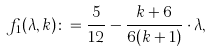Convert formula to latex. <formula><loc_0><loc_0><loc_500><loc_500>f _ { 1 } ( \lambda , k ) \colon = \frac { 5 } { 1 2 } - \frac { k + 6 } { 6 ( k + 1 ) } \cdot \lambda ,</formula> 